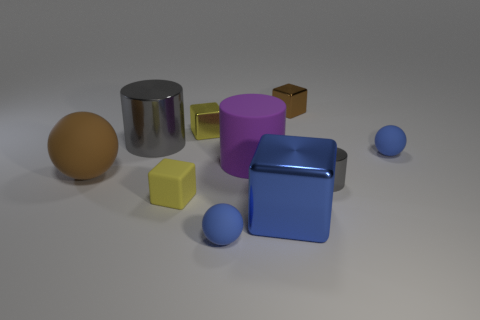Is the color of the large sphere the same as the matte ball behind the brown sphere?
Give a very brief answer. No. What number of things are either small blue metal balls or small blocks?
Your answer should be very brief. 3. Is there any other thing that has the same color as the tiny rubber cube?
Offer a very short reply. Yes. Does the large blue thing have the same material as the small gray thing that is in front of the big rubber cylinder?
Keep it short and to the point. Yes. What is the shape of the gray metallic thing that is on the right side of the big cube that is left of the brown block?
Keep it short and to the point. Cylinder. The shiny object that is on the right side of the blue metal thing and in front of the large brown rubber sphere has what shape?
Give a very brief answer. Cylinder. How many things are blue cubes or big blue shiny objects in front of the brown rubber object?
Give a very brief answer. 1. There is a brown object that is the same shape as the small yellow shiny thing; what is its material?
Offer a terse response. Metal. Is there anything else that is the same material as the large brown ball?
Make the answer very short. Yes. There is a cylinder that is to the right of the yellow metal block and to the left of the small gray metal cylinder; what material is it made of?
Offer a very short reply. Rubber. 